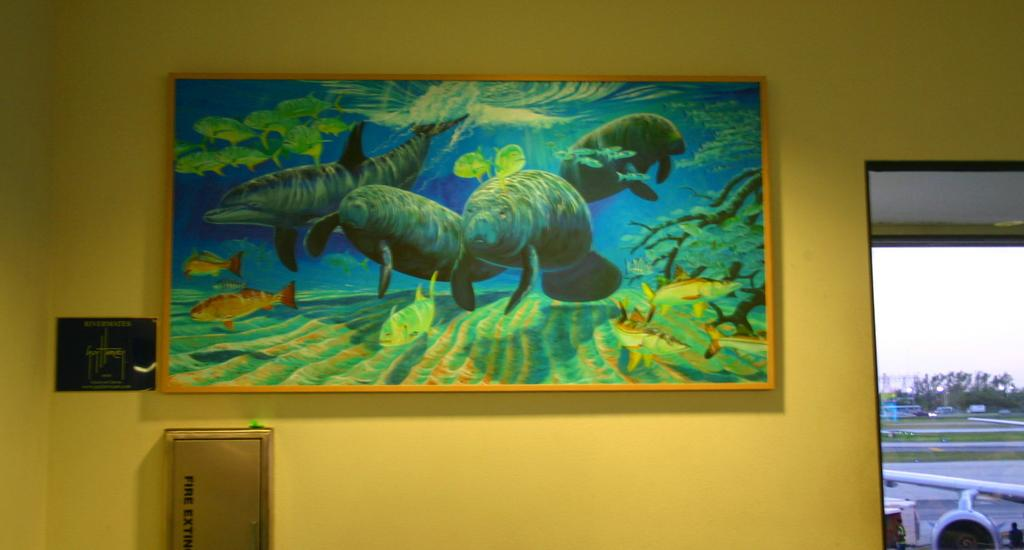What is located in the center of the image? There is a wall, a frame, and a screen in the center of the image. What is displayed on the screen? The screen displays the sky, with clouds, trees, grass, and an airplane visible. What type of natural environment is depicted on the screen? The screen shows a sky with clouds, trees, and grass, suggesting a natural outdoor setting. What color is the pen on the wall in the image? There is no pen present on the wall in the image. What month is it in the image? The image does not provide any information about the month or time of year. 